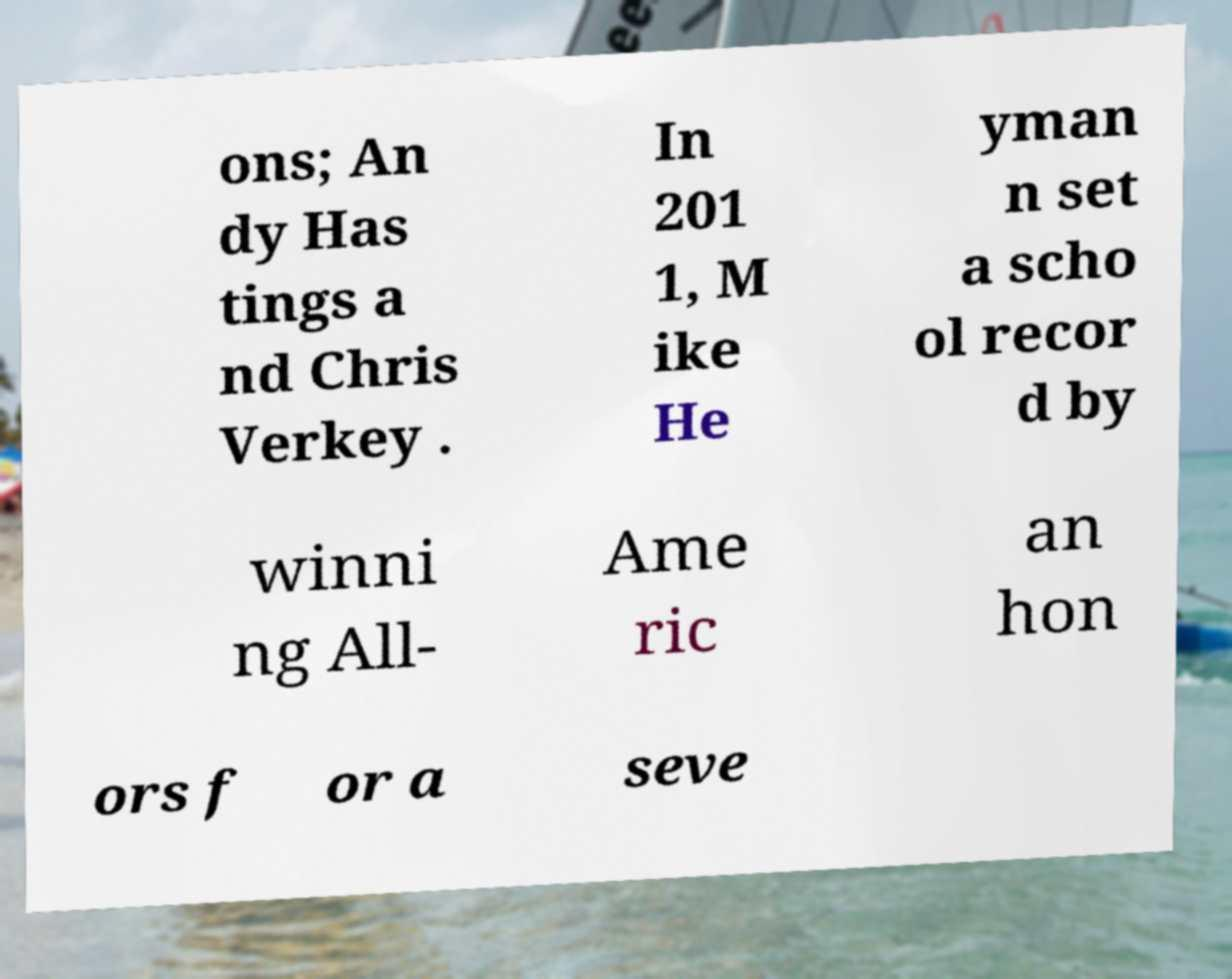I need the written content from this picture converted into text. Can you do that? ons; An dy Has tings a nd Chris Verkey . In 201 1, M ike He yman n set a scho ol recor d by winni ng All- Ame ric an hon ors f or a seve 